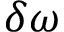<formula> <loc_0><loc_0><loc_500><loc_500>\delta \omega</formula> 